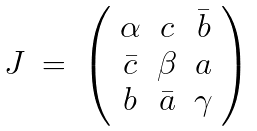Convert formula to latex. <formula><loc_0><loc_0><loc_500><loc_500>\begin{array} { c c c } { J } & { = } & { { \left ( \begin{array} { c c c } { \alpha } & { c } & { { \bar { b } } } \\ { { \bar { c } } } & { \beta } & { a } \\ { b } & { { \bar { a } } } & { \gamma } \end{array} \right ) } } \end{array}</formula> 